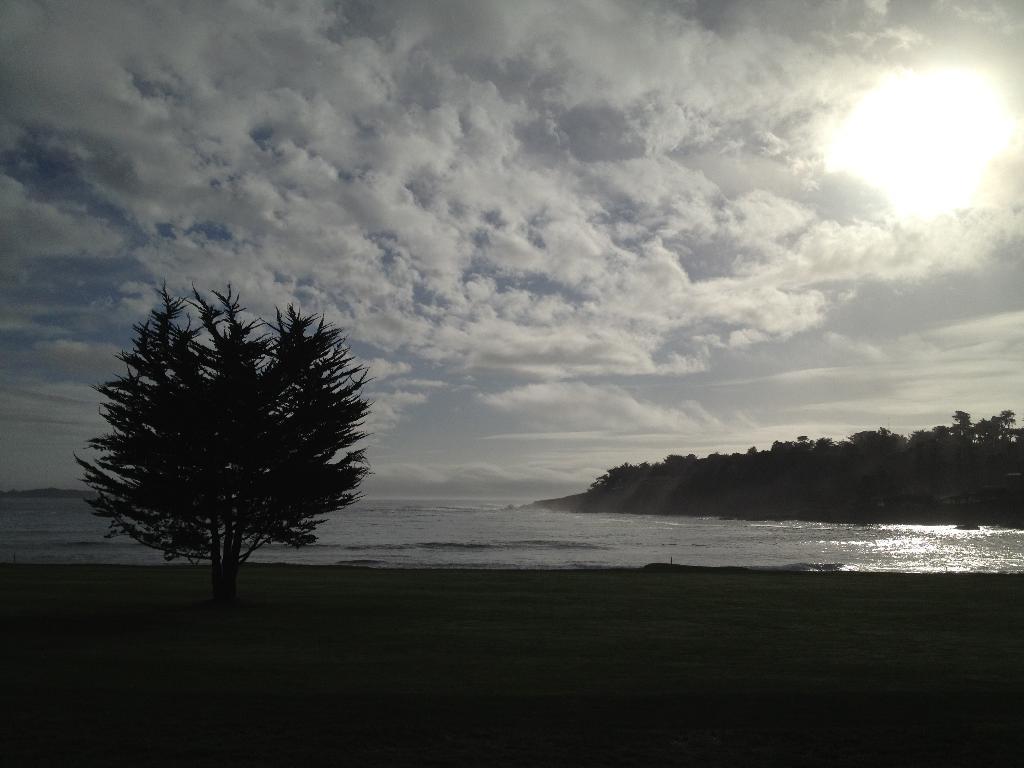Please provide a concise description of this image. This picture shows a few trees and we see water and a cloudy sky with sun and we see grass on the ground. 